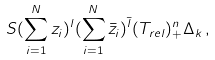Convert formula to latex. <formula><loc_0><loc_0><loc_500><loc_500>S ( \sum _ { i = 1 } ^ { N } z _ { i } ) ^ { l } ( \sum _ { i = 1 } ^ { N } \bar { z } _ { i } ) ^ { \bar { l } } ( T _ { r e l } ) _ { + } ^ { n } \Delta _ { k } \, ,</formula> 